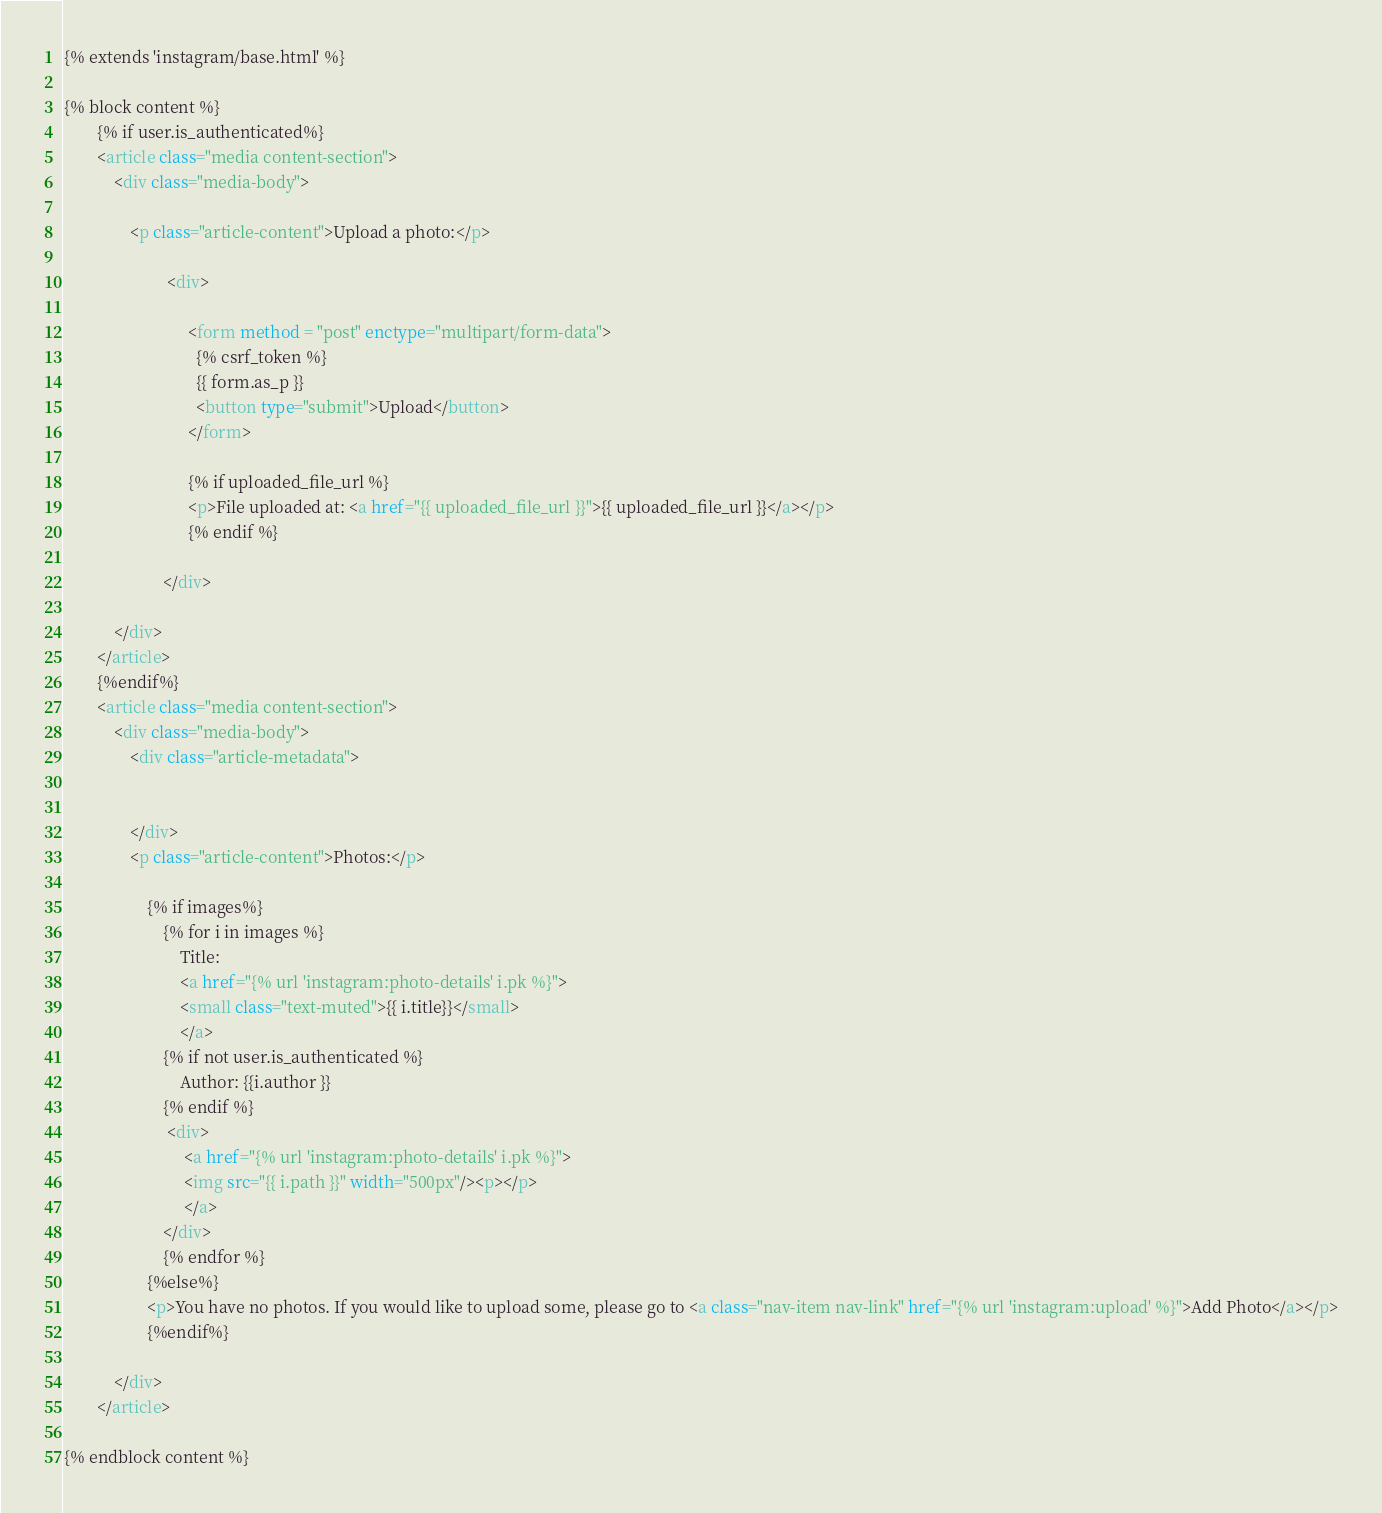Convert code to text. <code><loc_0><loc_0><loc_500><loc_500><_HTML_>{% extends 'instagram/base.html' %}

{% block content %}
        {% if user.is_authenticated%}
        <article class="media content-section">
            <div class="media-body">

                <p class="article-content">Upload a photo:</p>

                         <div>

                              <form method = "post" enctype="multipart/form-data">
                                {% csrf_token %}
                                {{ form.as_p }}
                                <button type="submit">Upload</button>
                              </form>

                              {% if uploaded_file_url %}
                              <p>File uploaded at: <a href="{{ uploaded_file_url }}">{{ uploaded_file_url }}</a></p>
                              {% endif %}

                        </div>

            </div>
        </article>
        {%endif%}
        <article class="media content-section">
            <div class="media-body">
                <div class="article-metadata">


                </div>
                <p class="article-content">Photos:</p>

                    {% if images%}
                        {% for i in images %}
                            Title:
                            <a href="{% url 'instagram:photo-details' i.pk %}">
                            <small class="text-muted">{{ i.title}}</small>
                            </a>
                        {% if not user.is_authenticated %}
                            Author: {{i.author }}
                        {% endif %}
                         <div>
                             <a href="{% url 'instagram:photo-details' i.pk %}">
                             <img src="{{ i.path }}" width="500px"/><p></p>
                             </a>
                        </div>
                        {% endfor %}
                    {%else%}
                    <p>You have no photos. If you would like to upload some, please go to <a class="nav-item nav-link" href="{% url 'instagram:upload' %}">Add Photo</a></p>
                    {%endif%}

            </div>
        </article>

{% endblock content %}</code> 